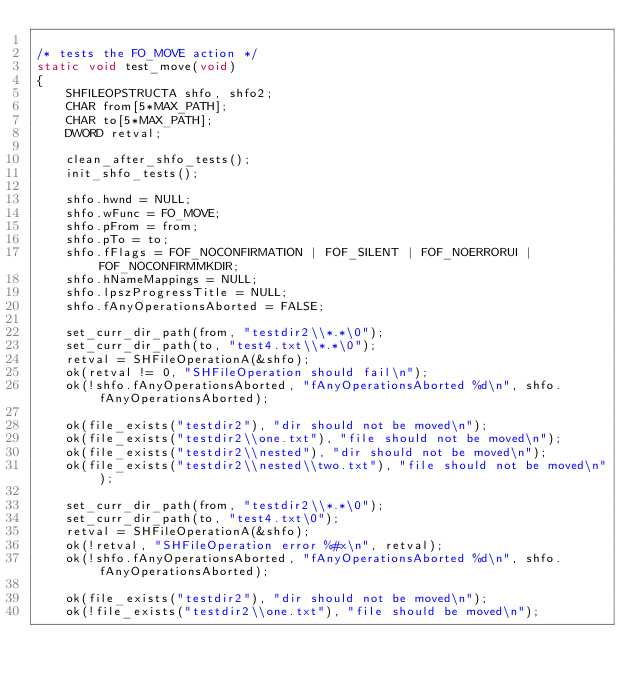Convert code to text. <code><loc_0><loc_0><loc_500><loc_500><_C_>
/* tests the FO_MOVE action */
static void test_move(void)
{
    SHFILEOPSTRUCTA shfo, shfo2;
    CHAR from[5*MAX_PATH];
    CHAR to[5*MAX_PATH];
    DWORD retval;

    clean_after_shfo_tests();
    init_shfo_tests();

    shfo.hwnd = NULL;
    shfo.wFunc = FO_MOVE;
    shfo.pFrom = from;
    shfo.pTo = to;
    shfo.fFlags = FOF_NOCONFIRMATION | FOF_SILENT | FOF_NOERRORUI | FOF_NOCONFIRMMKDIR;
    shfo.hNameMappings = NULL;
    shfo.lpszProgressTitle = NULL;
    shfo.fAnyOperationsAborted = FALSE;

    set_curr_dir_path(from, "testdir2\\*.*\0");
    set_curr_dir_path(to, "test4.txt\\*.*\0");
    retval = SHFileOperationA(&shfo);
    ok(retval != 0, "SHFileOperation should fail\n");
    ok(!shfo.fAnyOperationsAborted, "fAnyOperationsAborted %d\n", shfo.fAnyOperationsAborted);

    ok(file_exists("testdir2"), "dir should not be moved\n");
    ok(file_exists("testdir2\\one.txt"), "file should not be moved\n");
    ok(file_exists("testdir2\\nested"), "dir should not be moved\n");
    ok(file_exists("testdir2\\nested\\two.txt"), "file should not be moved\n");

    set_curr_dir_path(from, "testdir2\\*.*\0");
    set_curr_dir_path(to, "test4.txt\0");
    retval = SHFileOperationA(&shfo);
    ok(!retval, "SHFileOperation error %#x\n", retval);
    ok(!shfo.fAnyOperationsAborted, "fAnyOperationsAborted %d\n", shfo.fAnyOperationsAborted);

    ok(file_exists("testdir2"), "dir should not be moved\n");
    ok(!file_exists("testdir2\\one.txt"), "file should be moved\n");</code> 